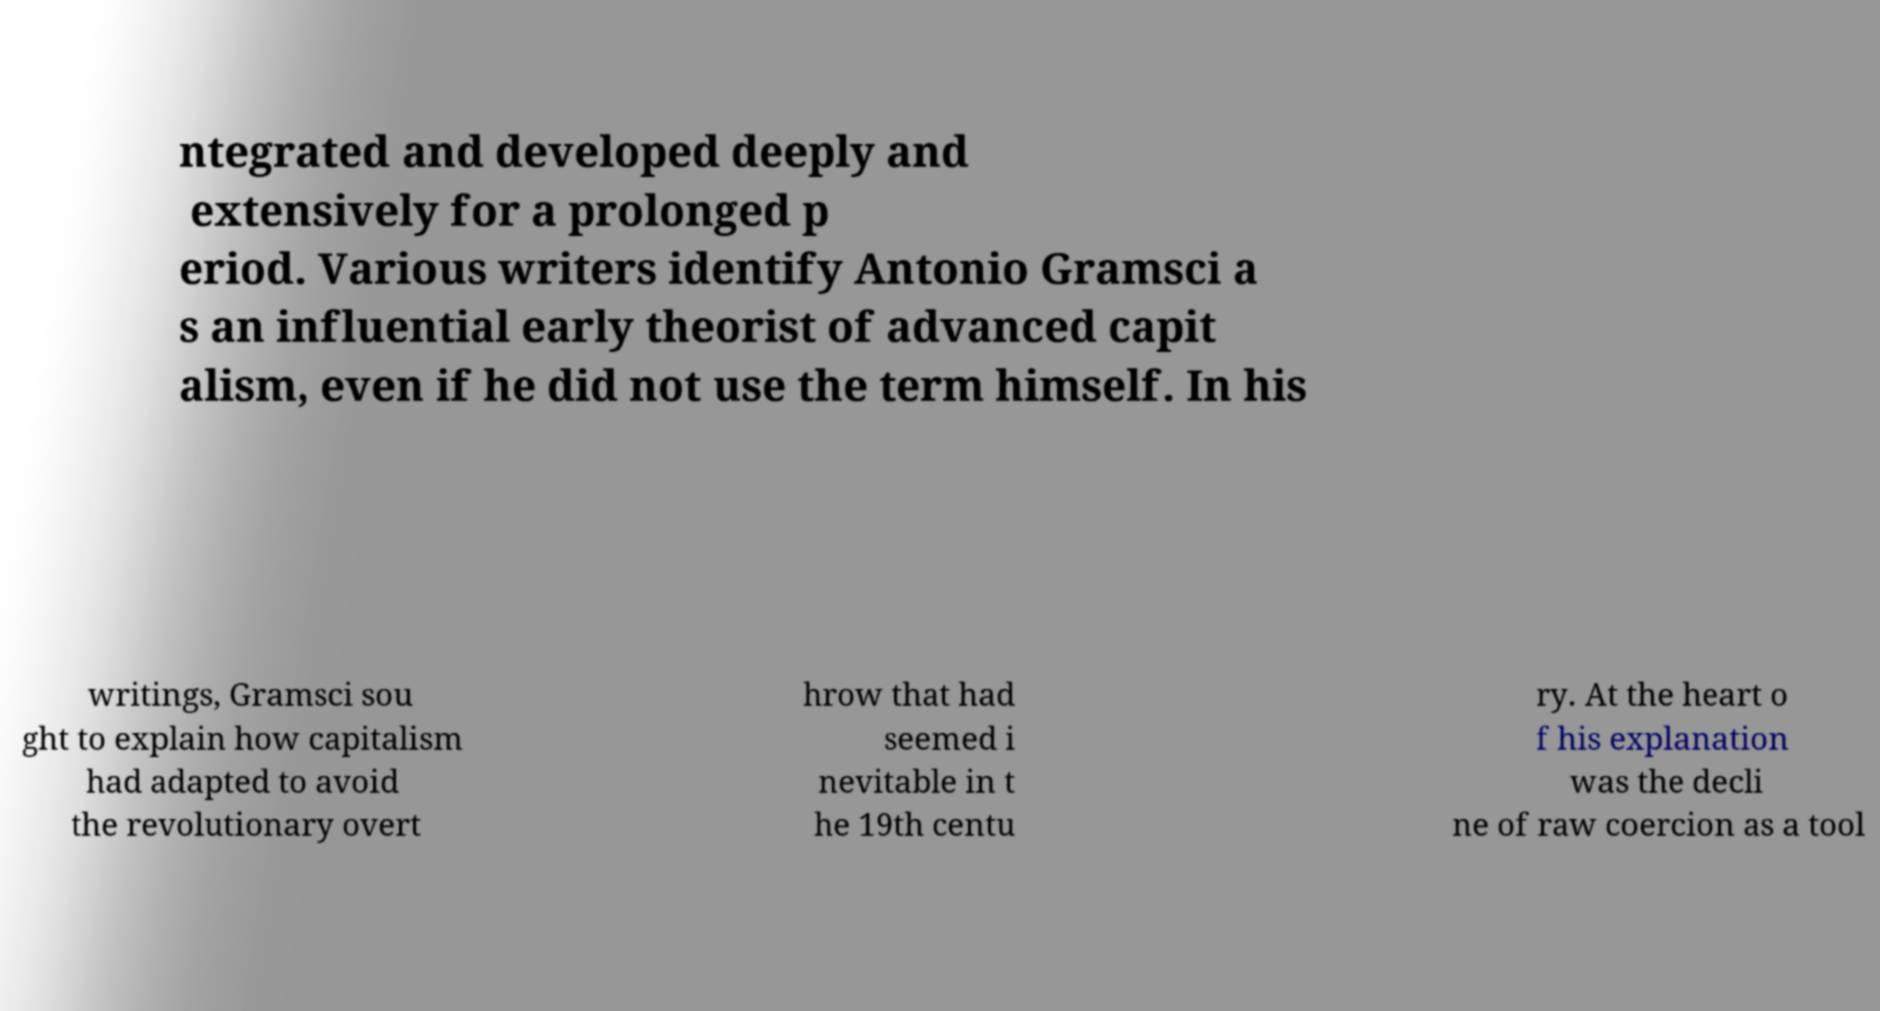Can you accurately transcribe the text from the provided image for me? ntegrated and developed deeply and extensively for a prolonged p eriod. Various writers identify Antonio Gramsci a s an influential early theorist of advanced capit alism, even if he did not use the term himself. In his writings, Gramsci sou ght to explain how capitalism had adapted to avoid the revolutionary overt hrow that had seemed i nevitable in t he 19th centu ry. At the heart o f his explanation was the decli ne of raw coercion as a tool 